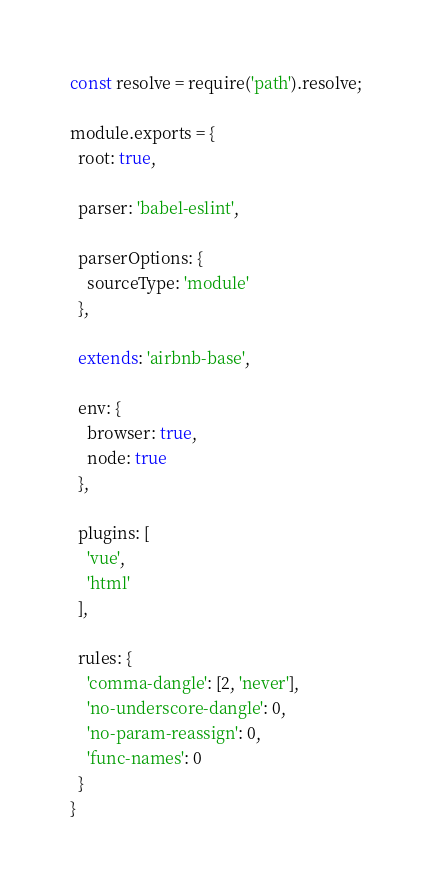Convert code to text. <code><loc_0><loc_0><loc_500><loc_500><_JavaScript_>const resolve = require('path').resolve;

module.exports = {
  root: true,

  parser: 'babel-eslint',

  parserOptions: {
    sourceType: 'module'
  },

  extends: 'airbnb-base',

  env: {
    browser: true,
    node: true
  },

  plugins: [
    'vue',
    'html'
  ],

  rules: {
    'comma-dangle': [2, 'never'],
    'no-underscore-dangle': 0,
    'no-param-reassign': 0,
    'func-names': 0
  }
}
</code> 